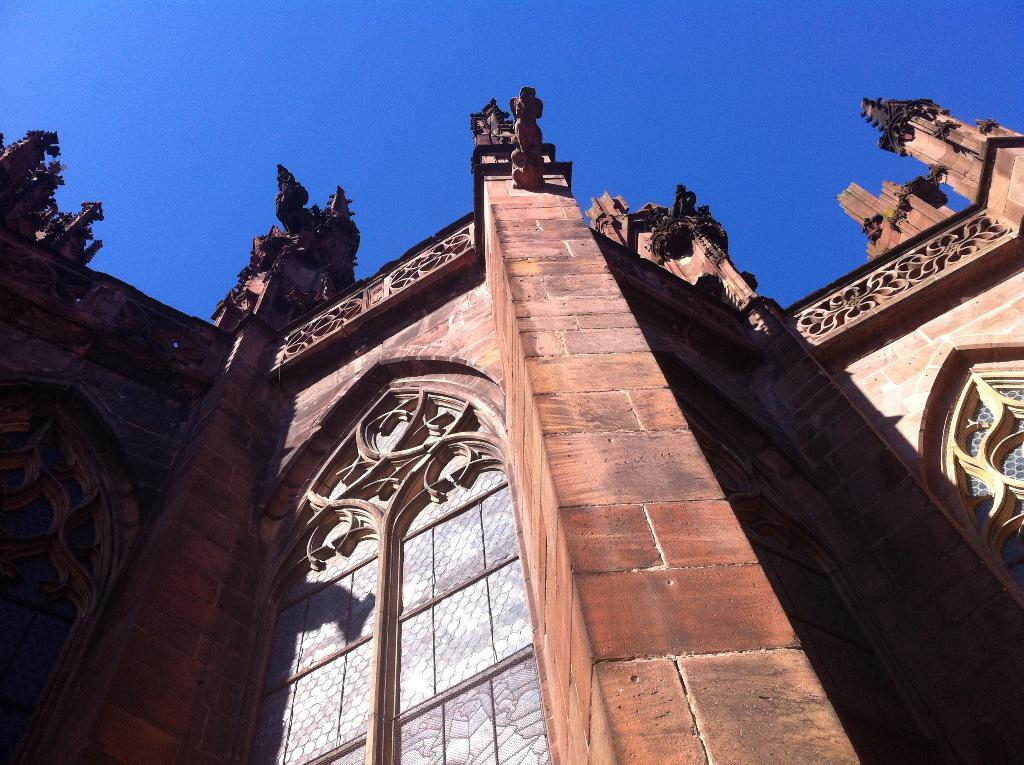What type of structures are present in the image? There are buildings in the image. What is a notable feature of the buildings? The buildings have red color brick walls. What is visible at the top of the image? The sky is visible at the top of the image. How would you describe the sky in the image? The sky is clear in the image. Can you tell me how many bats are flying around the buildings in the image? There are no bats present in the image; the focus is on the buildings and the clear sky. 